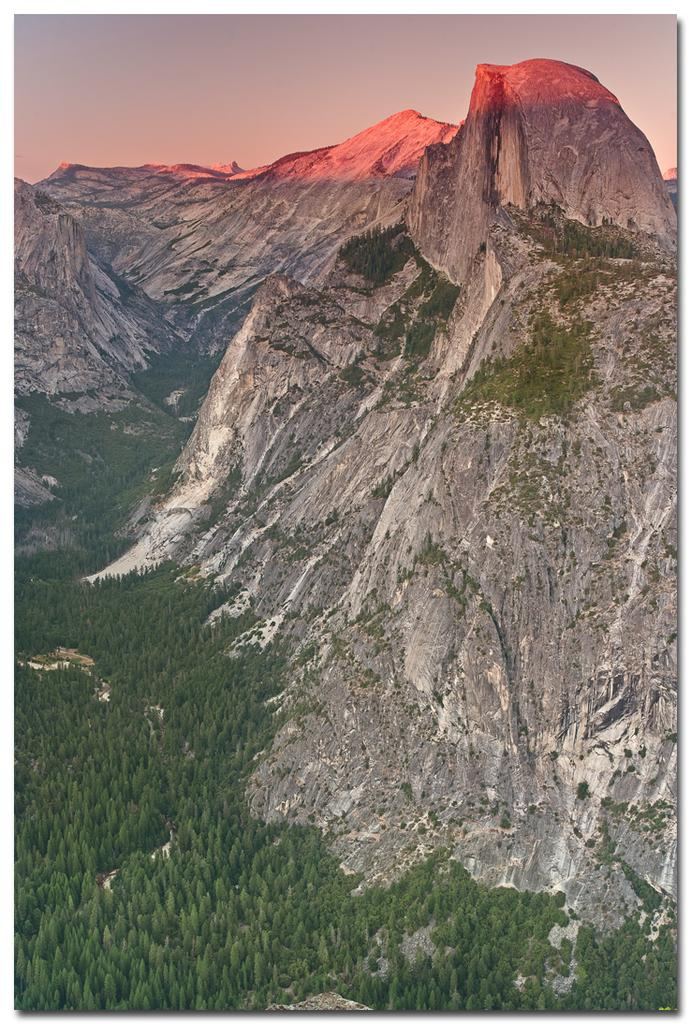What type of geographical feature can be seen in the image? There are hills in the image. What type of vegetation is present in the image? There are trees in the image. What is the condition of the sky in the image? The sky is cloudy in the image. What type of stem can be seen growing from the hills in the image? There are no stems visible in the image, as the hills are a geographical feature and not a plant. 